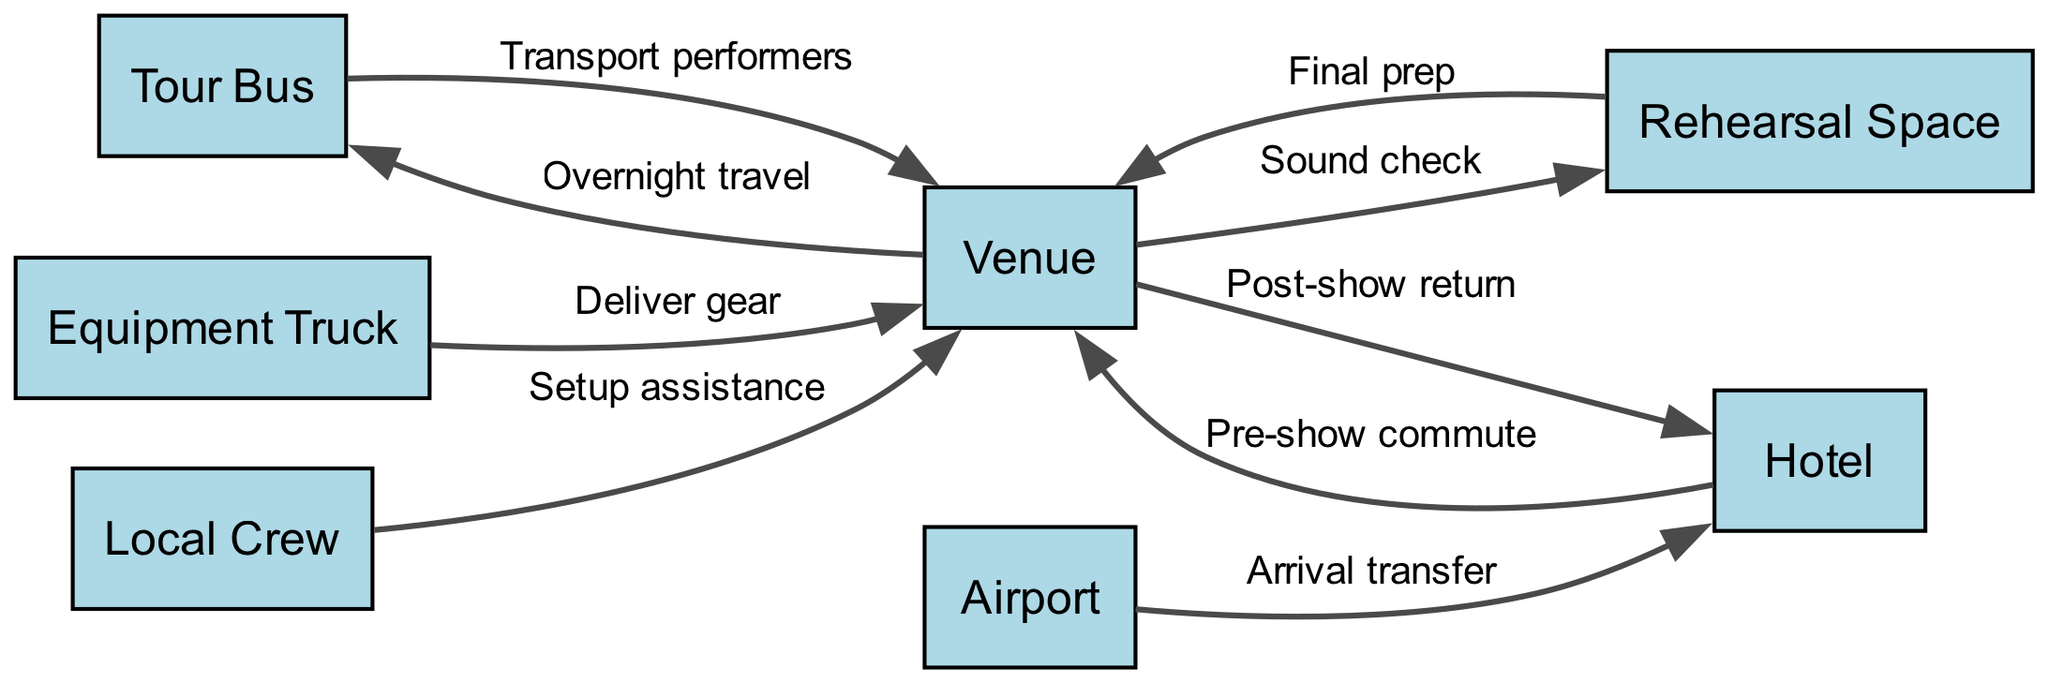What is the total number of nodes in the diagram? The nodes listed are "Tour Bus," "Venue," "Equipment Truck," "Airport," "Hotel," "Local Crew," and "Rehearsal Space." Counting these, there are a total of 7 nodes.
Answer: 7 What labels are associated with the edge between "Venue" and "Tour Bus"? The edge between "Venue" and "Tour Bus" has the label "Overnight travel," indicating the type of connection between these two nodes.
Answer: Overnight travel Which node receives equipment from the "Equipment Truck"? The "Equipment Truck" has an edge that points to "Venue," which indicates that the equipment from the truck is delivered there.
Answer: Venue What is the purpose of the edge from "Venue" to "Rehearsal Space"? The label on the edge from "Venue" to "Rehearsal Space" is "Sound check," indicating that this connection represents the flow of action for conducting sound checks before a show.
Answer: Sound check Which node is the starting point for the "Arrival transfer"? The edge labeled "Arrival transfer" starts from "Airport" and leads to "Hotel," indicating that "Airport" is the node where the transfer begins.
Answer: Airport What process follows the "Pre-show commute"? After the "Pre-show commute" from "Hotel" to "Venue," the next step is the performance at the venue, but it is also indicated by the arrow leading to "Local Crew" for assistance in setup.
Answer: Venue How many edges connect to the "Venue"? Counting the edges that point to or from "Venue," we find there are 6 connections, indicating various processes like setup, commuting, and equipment delivery.
Answer: 6 Which nodes are directly involved in setup assistance? The "Local Crew" node has a direct edge to "Venue," labeled "Setup assistance," meaning they are involved in the setup process for the show.
Answer: Local Crew What is the sequential order of actions starting from the "Rehearsal Space" to "Venue"? The edge from "Rehearsal Space" to "Venue" is labeled "Final prep," indicating that it's the last step before proceeding to the venue for the show after rehearsals.
Answer: Final prep 